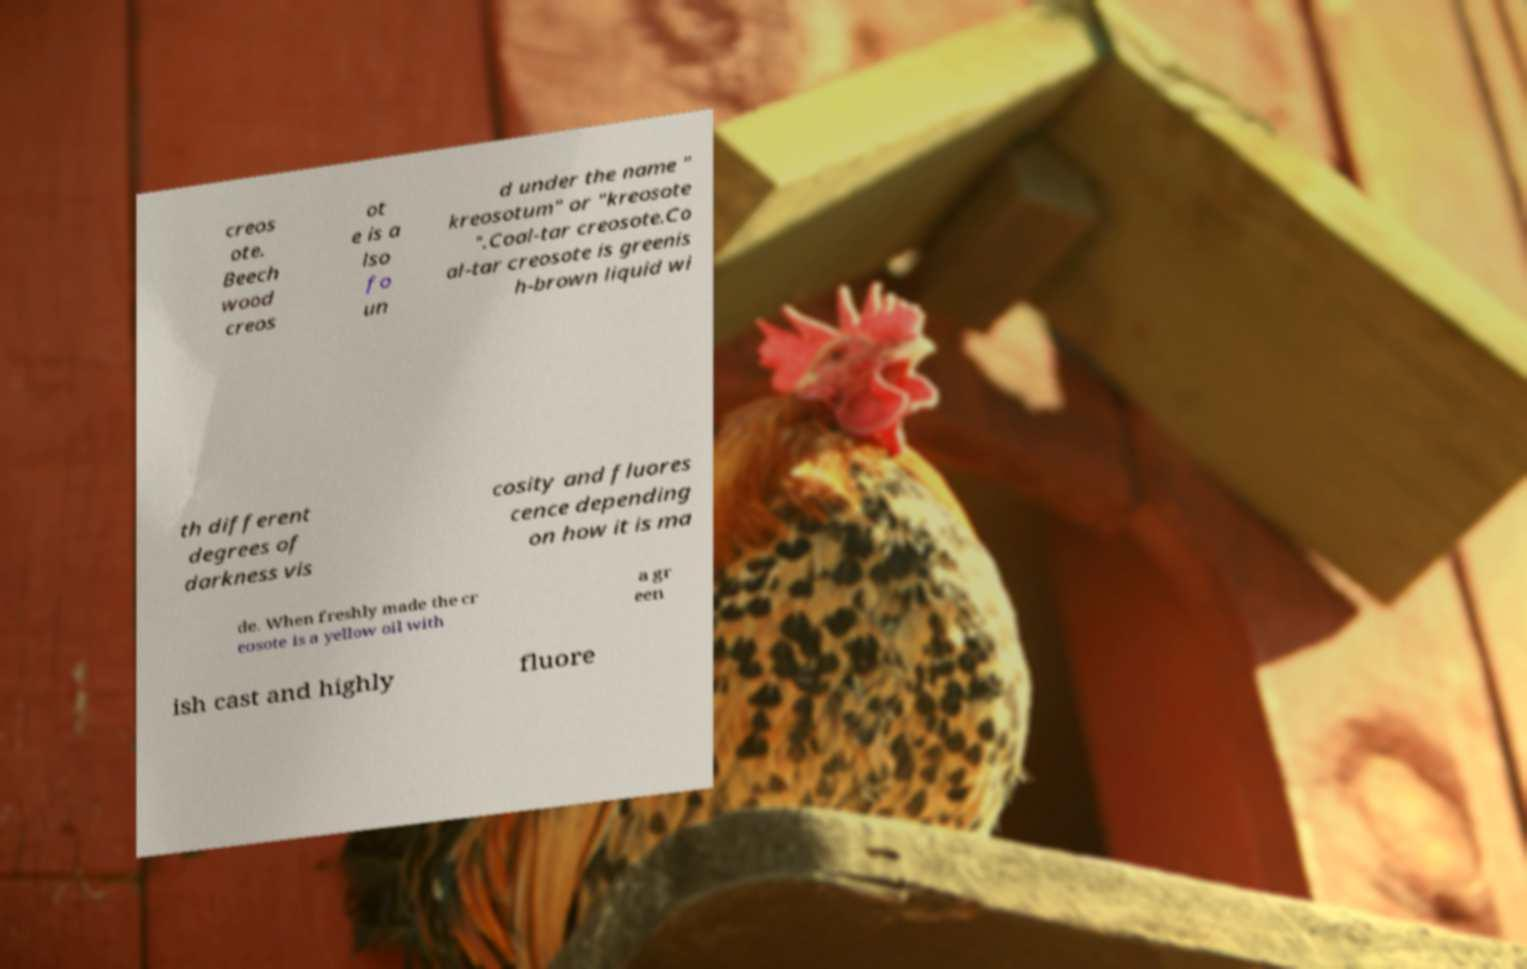Could you extract and type out the text from this image? creos ote. Beech wood creos ot e is a lso fo un d under the name " kreosotum" or "kreosote ".Coal-tar creosote.Co al-tar creosote is greenis h-brown liquid wi th different degrees of darkness vis cosity and fluores cence depending on how it is ma de. When freshly made the cr eosote is a yellow oil with a gr een ish cast and highly fluore 